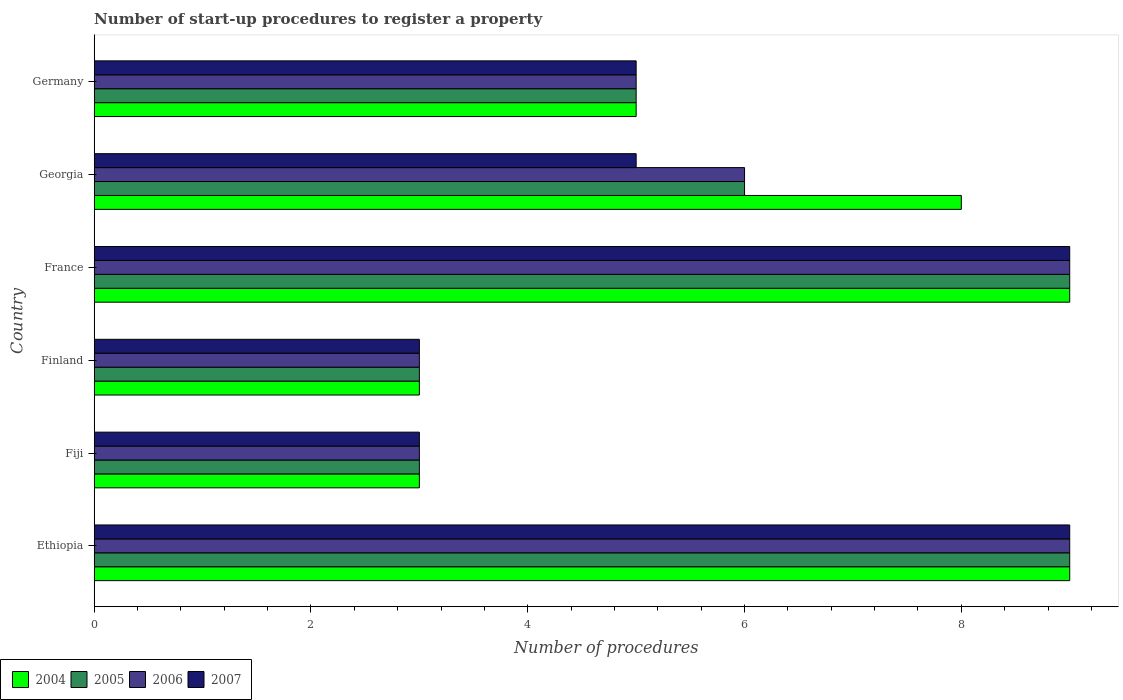How many groups of bars are there?
Your response must be concise. 6. Are the number of bars per tick equal to the number of legend labels?
Provide a short and direct response. Yes. Across all countries, what is the maximum number of procedures required to register a property in 2004?
Ensure brevity in your answer.  9. In which country was the number of procedures required to register a property in 2004 maximum?
Make the answer very short. Ethiopia. In which country was the number of procedures required to register a property in 2005 minimum?
Your answer should be compact. Fiji. What is the average number of procedures required to register a property in 2007 per country?
Provide a succinct answer. 5.67. What is the difference between the number of procedures required to register a property in 2006 and number of procedures required to register a property in 2004 in Finland?
Keep it short and to the point. 0. Is the number of procedures required to register a property in 2004 in Ethiopia less than that in Fiji?
Give a very brief answer. No. What is the difference between the highest and the second highest number of procedures required to register a property in 2007?
Keep it short and to the point. 0. In how many countries, is the number of procedures required to register a property in 2006 greater than the average number of procedures required to register a property in 2006 taken over all countries?
Ensure brevity in your answer.  3. Is it the case that in every country, the sum of the number of procedures required to register a property in 2005 and number of procedures required to register a property in 2004 is greater than the sum of number of procedures required to register a property in 2007 and number of procedures required to register a property in 2006?
Offer a terse response. No. What does the 2nd bar from the top in Georgia represents?
Make the answer very short. 2006. What does the 3rd bar from the bottom in Ethiopia represents?
Offer a terse response. 2006. How many bars are there?
Ensure brevity in your answer.  24. Are all the bars in the graph horizontal?
Make the answer very short. Yes. How many countries are there in the graph?
Your answer should be very brief. 6. What is the difference between two consecutive major ticks on the X-axis?
Ensure brevity in your answer.  2. Does the graph contain grids?
Your answer should be compact. No. Where does the legend appear in the graph?
Ensure brevity in your answer.  Bottom left. What is the title of the graph?
Your answer should be compact. Number of start-up procedures to register a property. What is the label or title of the X-axis?
Keep it short and to the point. Number of procedures. What is the Number of procedures of 2004 in Ethiopia?
Give a very brief answer. 9. What is the Number of procedures in 2004 in Fiji?
Offer a very short reply. 3. What is the Number of procedures in 2005 in Fiji?
Give a very brief answer. 3. What is the Number of procedures of 2004 in Finland?
Make the answer very short. 3. What is the Number of procedures of 2005 in Finland?
Make the answer very short. 3. What is the Number of procedures in 2007 in Finland?
Offer a very short reply. 3. What is the Number of procedures of 2005 in France?
Offer a terse response. 9. What is the Number of procedures of 2006 in France?
Offer a very short reply. 9. What is the Number of procedures of 2005 in Georgia?
Your answer should be compact. 6. What is the Number of procedures in 2004 in Germany?
Keep it short and to the point. 5. What is the Number of procedures in 2005 in Germany?
Ensure brevity in your answer.  5. What is the Number of procedures in 2006 in Germany?
Your answer should be very brief. 5. Across all countries, what is the maximum Number of procedures in 2004?
Provide a short and direct response. 9. Across all countries, what is the maximum Number of procedures of 2005?
Your response must be concise. 9. Across all countries, what is the maximum Number of procedures in 2007?
Make the answer very short. 9. Across all countries, what is the minimum Number of procedures of 2004?
Your response must be concise. 3. Across all countries, what is the minimum Number of procedures in 2006?
Ensure brevity in your answer.  3. What is the total Number of procedures in 2005 in the graph?
Make the answer very short. 35. What is the total Number of procedures of 2006 in the graph?
Provide a short and direct response. 35. What is the difference between the Number of procedures of 2005 in Ethiopia and that in Fiji?
Your response must be concise. 6. What is the difference between the Number of procedures of 2007 in Ethiopia and that in Fiji?
Offer a terse response. 6. What is the difference between the Number of procedures of 2004 in Ethiopia and that in Finland?
Your answer should be compact. 6. What is the difference between the Number of procedures in 2006 in Ethiopia and that in Finland?
Provide a short and direct response. 6. What is the difference between the Number of procedures of 2007 in Ethiopia and that in Finland?
Your answer should be compact. 6. What is the difference between the Number of procedures of 2005 in Ethiopia and that in France?
Provide a short and direct response. 0. What is the difference between the Number of procedures of 2004 in Ethiopia and that in Georgia?
Provide a short and direct response. 1. What is the difference between the Number of procedures in 2005 in Ethiopia and that in Georgia?
Ensure brevity in your answer.  3. What is the difference between the Number of procedures in 2004 in Ethiopia and that in Germany?
Your response must be concise. 4. What is the difference between the Number of procedures of 2005 in Ethiopia and that in Germany?
Offer a very short reply. 4. What is the difference between the Number of procedures of 2006 in Ethiopia and that in Germany?
Provide a short and direct response. 4. What is the difference between the Number of procedures of 2007 in Ethiopia and that in Germany?
Your answer should be very brief. 4. What is the difference between the Number of procedures of 2006 in Fiji and that in Finland?
Your answer should be compact. 0. What is the difference between the Number of procedures of 2005 in Fiji and that in France?
Keep it short and to the point. -6. What is the difference between the Number of procedures in 2006 in Fiji and that in France?
Your response must be concise. -6. What is the difference between the Number of procedures of 2007 in Fiji and that in France?
Your answer should be compact. -6. What is the difference between the Number of procedures of 2004 in Fiji and that in Germany?
Keep it short and to the point. -2. What is the difference between the Number of procedures in 2004 in Finland and that in France?
Offer a very short reply. -6. What is the difference between the Number of procedures in 2005 in Finland and that in France?
Provide a short and direct response. -6. What is the difference between the Number of procedures of 2006 in Finland and that in Georgia?
Offer a very short reply. -3. What is the difference between the Number of procedures of 2007 in Finland and that in Georgia?
Offer a terse response. -2. What is the difference between the Number of procedures in 2004 in Finland and that in Germany?
Make the answer very short. -2. What is the difference between the Number of procedures in 2005 in Finland and that in Germany?
Provide a succinct answer. -2. What is the difference between the Number of procedures in 2006 in Finland and that in Germany?
Provide a succinct answer. -2. What is the difference between the Number of procedures of 2004 in France and that in Germany?
Offer a very short reply. 4. What is the difference between the Number of procedures of 2006 in France and that in Germany?
Offer a very short reply. 4. What is the difference between the Number of procedures of 2007 in France and that in Germany?
Offer a very short reply. 4. What is the difference between the Number of procedures of 2004 in Georgia and that in Germany?
Offer a terse response. 3. What is the difference between the Number of procedures of 2005 in Georgia and that in Germany?
Provide a short and direct response. 1. What is the difference between the Number of procedures of 2006 in Georgia and that in Germany?
Your answer should be very brief. 1. What is the difference between the Number of procedures in 2007 in Georgia and that in Germany?
Offer a very short reply. 0. What is the difference between the Number of procedures of 2004 in Ethiopia and the Number of procedures of 2006 in Fiji?
Provide a succinct answer. 6. What is the difference between the Number of procedures of 2005 in Ethiopia and the Number of procedures of 2006 in Fiji?
Ensure brevity in your answer.  6. What is the difference between the Number of procedures in 2004 in Ethiopia and the Number of procedures in 2005 in Finland?
Make the answer very short. 6. What is the difference between the Number of procedures of 2004 in Ethiopia and the Number of procedures of 2006 in Finland?
Keep it short and to the point. 6. What is the difference between the Number of procedures in 2004 in Ethiopia and the Number of procedures in 2007 in Finland?
Give a very brief answer. 6. What is the difference between the Number of procedures in 2005 in Ethiopia and the Number of procedures in 2006 in Finland?
Give a very brief answer. 6. What is the difference between the Number of procedures in 2005 in Ethiopia and the Number of procedures in 2007 in Finland?
Your answer should be very brief. 6. What is the difference between the Number of procedures of 2006 in Ethiopia and the Number of procedures of 2007 in Finland?
Make the answer very short. 6. What is the difference between the Number of procedures in 2004 in Ethiopia and the Number of procedures in 2005 in France?
Your answer should be very brief. 0. What is the difference between the Number of procedures in 2004 in Ethiopia and the Number of procedures in 2006 in France?
Ensure brevity in your answer.  0. What is the difference between the Number of procedures of 2004 in Ethiopia and the Number of procedures of 2007 in France?
Offer a very short reply. 0. What is the difference between the Number of procedures in 2004 in Ethiopia and the Number of procedures in 2005 in Georgia?
Offer a terse response. 3. What is the difference between the Number of procedures in 2004 in Ethiopia and the Number of procedures in 2007 in Georgia?
Offer a terse response. 4. What is the difference between the Number of procedures in 2005 in Ethiopia and the Number of procedures in 2006 in Georgia?
Provide a short and direct response. 3. What is the difference between the Number of procedures in 2005 in Ethiopia and the Number of procedures in 2007 in Georgia?
Ensure brevity in your answer.  4. What is the difference between the Number of procedures in 2006 in Ethiopia and the Number of procedures in 2007 in Germany?
Offer a terse response. 4. What is the difference between the Number of procedures in 2004 in Fiji and the Number of procedures in 2005 in Finland?
Ensure brevity in your answer.  0. What is the difference between the Number of procedures in 2004 in Fiji and the Number of procedures in 2006 in Finland?
Keep it short and to the point. 0. What is the difference between the Number of procedures of 2005 in Fiji and the Number of procedures of 2006 in Finland?
Your response must be concise. 0. What is the difference between the Number of procedures in 2005 in Fiji and the Number of procedures in 2007 in Finland?
Give a very brief answer. 0. What is the difference between the Number of procedures in 2004 in Fiji and the Number of procedures in 2006 in France?
Your response must be concise. -6. What is the difference between the Number of procedures in 2004 in Fiji and the Number of procedures in 2007 in France?
Give a very brief answer. -6. What is the difference between the Number of procedures in 2005 in Fiji and the Number of procedures in 2006 in France?
Keep it short and to the point. -6. What is the difference between the Number of procedures of 2005 in Fiji and the Number of procedures of 2007 in France?
Provide a succinct answer. -6. What is the difference between the Number of procedures in 2004 in Fiji and the Number of procedures in 2005 in Georgia?
Your response must be concise. -3. What is the difference between the Number of procedures in 2006 in Fiji and the Number of procedures in 2007 in Georgia?
Your response must be concise. -2. What is the difference between the Number of procedures in 2004 in Fiji and the Number of procedures in 2005 in Germany?
Make the answer very short. -2. What is the difference between the Number of procedures of 2005 in Fiji and the Number of procedures of 2006 in Germany?
Give a very brief answer. -2. What is the difference between the Number of procedures in 2005 in Fiji and the Number of procedures in 2007 in Germany?
Your response must be concise. -2. What is the difference between the Number of procedures of 2004 in Finland and the Number of procedures of 2005 in France?
Keep it short and to the point. -6. What is the difference between the Number of procedures in 2006 in Finland and the Number of procedures in 2007 in France?
Keep it short and to the point. -6. What is the difference between the Number of procedures in 2004 in Finland and the Number of procedures in 2005 in Georgia?
Offer a very short reply. -3. What is the difference between the Number of procedures of 2004 in Finland and the Number of procedures of 2007 in Georgia?
Your response must be concise. -2. What is the difference between the Number of procedures of 2005 in Finland and the Number of procedures of 2007 in Georgia?
Ensure brevity in your answer.  -2. What is the difference between the Number of procedures in 2006 in Finland and the Number of procedures in 2007 in Georgia?
Give a very brief answer. -2. What is the difference between the Number of procedures of 2004 in Finland and the Number of procedures of 2006 in Germany?
Provide a short and direct response. -2. What is the difference between the Number of procedures of 2004 in Finland and the Number of procedures of 2007 in Germany?
Ensure brevity in your answer.  -2. What is the difference between the Number of procedures in 2005 in Finland and the Number of procedures in 2006 in Germany?
Your answer should be compact. -2. What is the difference between the Number of procedures of 2006 in Finland and the Number of procedures of 2007 in Germany?
Keep it short and to the point. -2. What is the difference between the Number of procedures of 2004 in France and the Number of procedures of 2005 in Georgia?
Provide a short and direct response. 3. What is the difference between the Number of procedures of 2004 in France and the Number of procedures of 2006 in Georgia?
Make the answer very short. 3. What is the difference between the Number of procedures of 2004 in France and the Number of procedures of 2007 in Georgia?
Keep it short and to the point. 4. What is the difference between the Number of procedures of 2005 in France and the Number of procedures of 2006 in Georgia?
Ensure brevity in your answer.  3. What is the difference between the Number of procedures in 2005 in France and the Number of procedures in 2007 in Georgia?
Ensure brevity in your answer.  4. What is the difference between the Number of procedures of 2004 in France and the Number of procedures of 2005 in Germany?
Your answer should be compact. 4. What is the difference between the Number of procedures of 2004 in France and the Number of procedures of 2006 in Germany?
Provide a succinct answer. 4. What is the difference between the Number of procedures in 2004 in Georgia and the Number of procedures in 2007 in Germany?
Provide a short and direct response. 3. What is the difference between the Number of procedures of 2005 in Georgia and the Number of procedures of 2006 in Germany?
Your response must be concise. 1. What is the average Number of procedures of 2004 per country?
Offer a very short reply. 6.17. What is the average Number of procedures in 2005 per country?
Make the answer very short. 5.83. What is the average Number of procedures in 2006 per country?
Offer a terse response. 5.83. What is the average Number of procedures in 2007 per country?
Provide a succinct answer. 5.67. What is the difference between the Number of procedures in 2004 and Number of procedures in 2005 in Ethiopia?
Your answer should be compact. 0. What is the difference between the Number of procedures of 2004 and Number of procedures of 2007 in Ethiopia?
Offer a very short reply. 0. What is the difference between the Number of procedures in 2005 and Number of procedures in 2007 in Ethiopia?
Provide a short and direct response. 0. What is the difference between the Number of procedures of 2006 and Number of procedures of 2007 in Ethiopia?
Offer a very short reply. 0. What is the difference between the Number of procedures in 2004 and Number of procedures in 2005 in Fiji?
Ensure brevity in your answer.  0. What is the difference between the Number of procedures of 2005 and Number of procedures of 2006 in Fiji?
Give a very brief answer. 0. What is the difference between the Number of procedures in 2005 and Number of procedures in 2007 in Fiji?
Ensure brevity in your answer.  0. What is the difference between the Number of procedures of 2006 and Number of procedures of 2007 in Fiji?
Ensure brevity in your answer.  0. What is the difference between the Number of procedures in 2004 and Number of procedures in 2005 in Finland?
Make the answer very short. 0. What is the difference between the Number of procedures of 2005 and Number of procedures of 2007 in Finland?
Offer a very short reply. 0. What is the difference between the Number of procedures in 2004 and Number of procedures in 2005 in France?
Ensure brevity in your answer.  0. What is the difference between the Number of procedures in 2004 and Number of procedures in 2006 in France?
Your answer should be compact. 0. What is the difference between the Number of procedures in 2004 and Number of procedures in 2007 in France?
Your response must be concise. 0. What is the difference between the Number of procedures of 2005 and Number of procedures of 2006 in France?
Make the answer very short. 0. What is the difference between the Number of procedures of 2006 and Number of procedures of 2007 in France?
Your response must be concise. 0. What is the difference between the Number of procedures in 2004 and Number of procedures in 2005 in Georgia?
Your response must be concise. 2. What is the difference between the Number of procedures in 2005 and Number of procedures in 2007 in Georgia?
Give a very brief answer. 1. What is the difference between the Number of procedures in 2006 and Number of procedures in 2007 in Georgia?
Give a very brief answer. 1. What is the ratio of the Number of procedures in 2004 in Ethiopia to that in Finland?
Offer a terse response. 3. What is the ratio of the Number of procedures in 2006 in Ethiopia to that in Finland?
Ensure brevity in your answer.  3. What is the ratio of the Number of procedures in 2006 in Ethiopia to that in France?
Provide a short and direct response. 1. What is the ratio of the Number of procedures in 2005 in Ethiopia to that in Georgia?
Your answer should be very brief. 1.5. What is the ratio of the Number of procedures of 2007 in Ethiopia to that in Georgia?
Your response must be concise. 1.8. What is the ratio of the Number of procedures in 2006 in Ethiopia to that in Germany?
Ensure brevity in your answer.  1.8. What is the ratio of the Number of procedures of 2007 in Ethiopia to that in Germany?
Your answer should be very brief. 1.8. What is the ratio of the Number of procedures in 2005 in Fiji to that in Finland?
Your answer should be very brief. 1. What is the ratio of the Number of procedures of 2006 in Fiji to that in Finland?
Offer a very short reply. 1. What is the ratio of the Number of procedures of 2007 in Fiji to that in Finland?
Offer a terse response. 1. What is the ratio of the Number of procedures of 2004 in Fiji to that in France?
Your answer should be very brief. 0.33. What is the ratio of the Number of procedures of 2005 in Fiji to that in France?
Make the answer very short. 0.33. What is the ratio of the Number of procedures of 2007 in Fiji to that in France?
Give a very brief answer. 0.33. What is the ratio of the Number of procedures of 2004 in Fiji to that in Georgia?
Ensure brevity in your answer.  0.38. What is the ratio of the Number of procedures in 2006 in Fiji to that in Georgia?
Your answer should be compact. 0.5. What is the ratio of the Number of procedures in 2007 in Fiji to that in Germany?
Provide a short and direct response. 0.6. What is the ratio of the Number of procedures of 2004 in Finland to that in France?
Keep it short and to the point. 0.33. What is the ratio of the Number of procedures of 2005 in Finland to that in France?
Make the answer very short. 0.33. What is the ratio of the Number of procedures of 2006 in Finland to that in France?
Ensure brevity in your answer.  0.33. What is the ratio of the Number of procedures of 2006 in Finland to that in Georgia?
Your response must be concise. 0.5. What is the ratio of the Number of procedures in 2007 in Finland to that in Georgia?
Keep it short and to the point. 0.6. What is the ratio of the Number of procedures of 2004 in Finland to that in Germany?
Provide a short and direct response. 0.6. What is the ratio of the Number of procedures in 2006 in Finland to that in Germany?
Your answer should be compact. 0.6. What is the ratio of the Number of procedures of 2005 in France to that in Georgia?
Give a very brief answer. 1.5. What is the ratio of the Number of procedures of 2006 in France to that in Georgia?
Provide a short and direct response. 1.5. What is the ratio of the Number of procedures in 2007 in France to that in Georgia?
Give a very brief answer. 1.8. What is the ratio of the Number of procedures of 2005 in France to that in Germany?
Your answer should be compact. 1.8. What is the ratio of the Number of procedures in 2006 in France to that in Germany?
Give a very brief answer. 1.8. What is the difference between the highest and the second highest Number of procedures in 2006?
Offer a terse response. 0. What is the difference between the highest and the second highest Number of procedures of 2007?
Give a very brief answer. 0. What is the difference between the highest and the lowest Number of procedures in 2005?
Your answer should be very brief. 6. What is the difference between the highest and the lowest Number of procedures of 2006?
Your response must be concise. 6. 